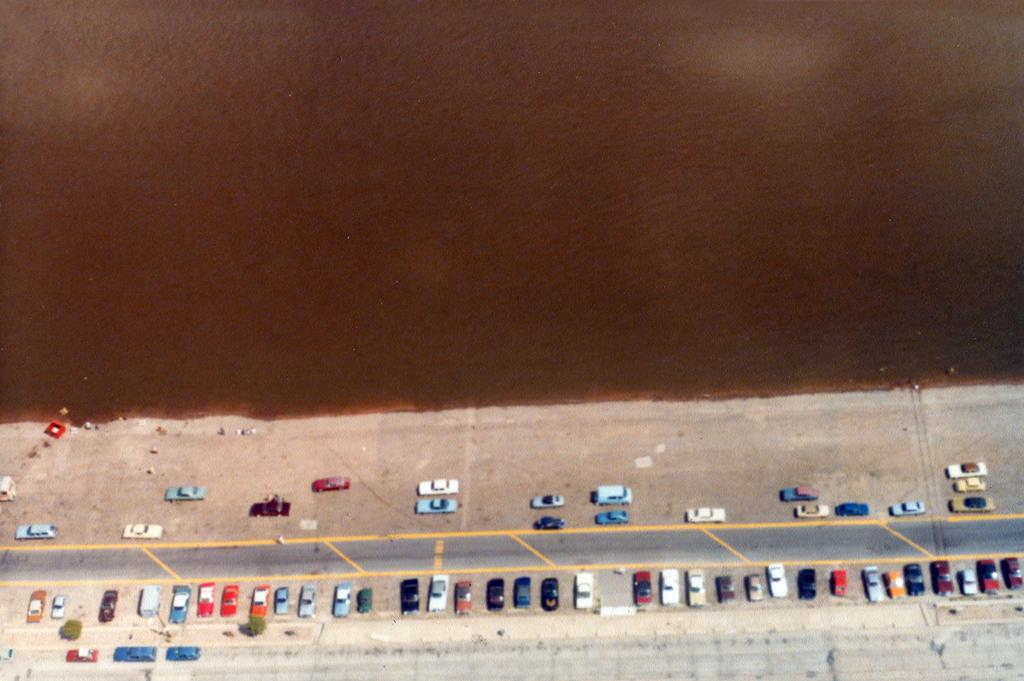What type of vehicles can be seen in the image? There are parked cars and moving cars in the image. What else is present in the image besides the cars? There are small bushes and a road in the image. What is the color of the background in the image? The background appears to be brown in color. What type of acoustics can be heard from the pet in the image? There is no pet present in the image, so it is not possible to determine the acoustics. 